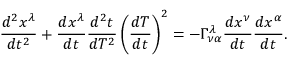Convert formula to latex. <formula><loc_0><loc_0><loc_500><loc_500>{ \frac { d ^ { 2 } x ^ { \lambda } } { d t ^ { 2 } } } + { \frac { d x ^ { \lambda } } { d t } } { \frac { d ^ { 2 } t } { d T ^ { 2 } } } \left ( { \frac { d T } { d t } } \right ) ^ { 2 } = - \Gamma _ { \nu \alpha } ^ { \lambda } { \frac { d x ^ { \nu } } { d t } } { \frac { d x ^ { \alpha } } { d t } } .</formula> 